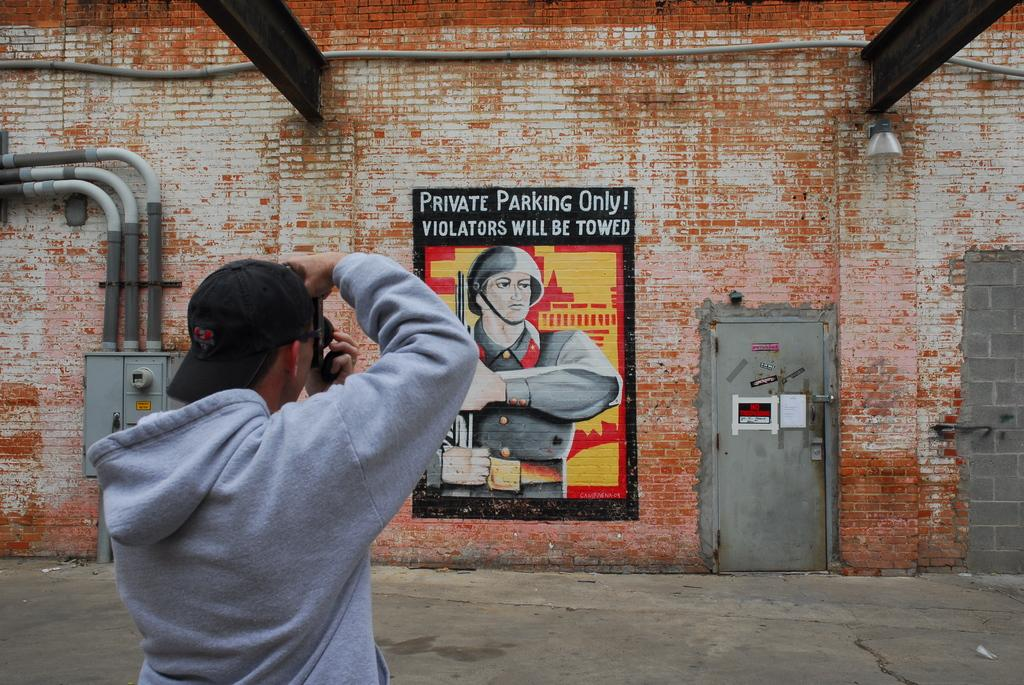What is the man in the image doing? The man is standing in the image and holding a camera in his hands. What can be seen near the man in the image? There is a door visible in the image. What architectural features are present in the image? There are pipes and a wall visible in the image. What is hanging on the wall in the image? There is a painting on the wall in the image. What is providing light in the image? There is a light source in the image. What type of animal can be seen swimming in the waves in the image? There are no animals or waves present in the image. 